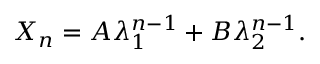<formula> <loc_0><loc_0><loc_500><loc_500>X _ { n } = A \lambda _ { 1 } ^ { n - 1 } + B \lambda _ { 2 } ^ { n - 1 } .</formula> 